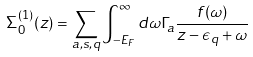<formula> <loc_0><loc_0><loc_500><loc_500>\Sigma ^ { ( 1 ) } _ { 0 } ( z ) = \sum _ { a , s , q } \int ^ { \infty } _ { - E _ { F } } d \omega \Gamma _ { a } \frac { f ( \omega ) } { z - \epsilon _ { q } + \omega }</formula> 